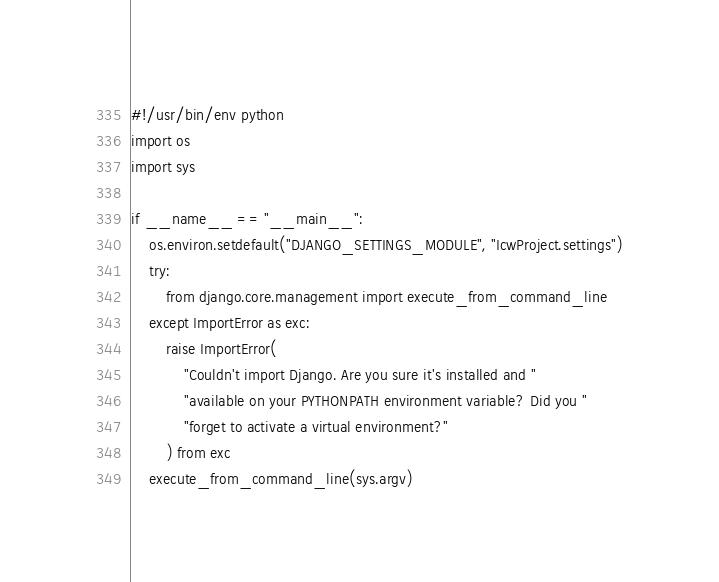<code> <loc_0><loc_0><loc_500><loc_500><_Python_>#!/usr/bin/env python
import os
import sys

if __name__ == "__main__":
    os.environ.setdefault("DJANGO_SETTINGS_MODULE", "IcwProject.settings")
    try:
        from django.core.management import execute_from_command_line
    except ImportError as exc:
        raise ImportError(
            "Couldn't import Django. Are you sure it's installed and "
            "available on your PYTHONPATH environment variable? Did you "
            "forget to activate a virtual environment?"
        ) from exc
    execute_from_command_line(sys.argv)
</code> 